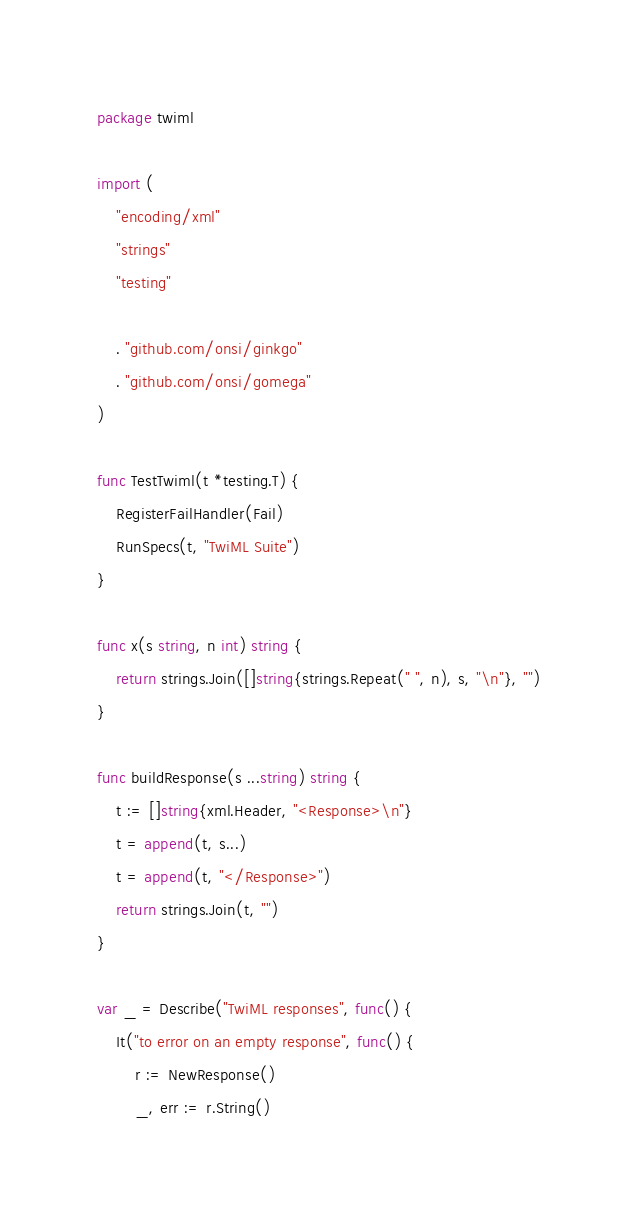<code> <loc_0><loc_0><loc_500><loc_500><_Go_>package twiml

import (
	"encoding/xml"
	"strings"
	"testing"

	. "github.com/onsi/ginkgo"
	. "github.com/onsi/gomega"
)

func TestTwiml(t *testing.T) {
	RegisterFailHandler(Fail)
	RunSpecs(t, "TwiML Suite")
}

func x(s string, n int) string {
	return strings.Join([]string{strings.Repeat(" ", n), s, "\n"}, "")
}

func buildResponse(s ...string) string {
	t := []string{xml.Header, "<Response>\n"}
	t = append(t, s...)
	t = append(t, "</Response>")
	return strings.Join(t, "")
}

var _ = Describe("TwiML responses", func() {
	It("to error on an empty response", func() {
		r := NewResponse()
		_, err := r.String()</code> 